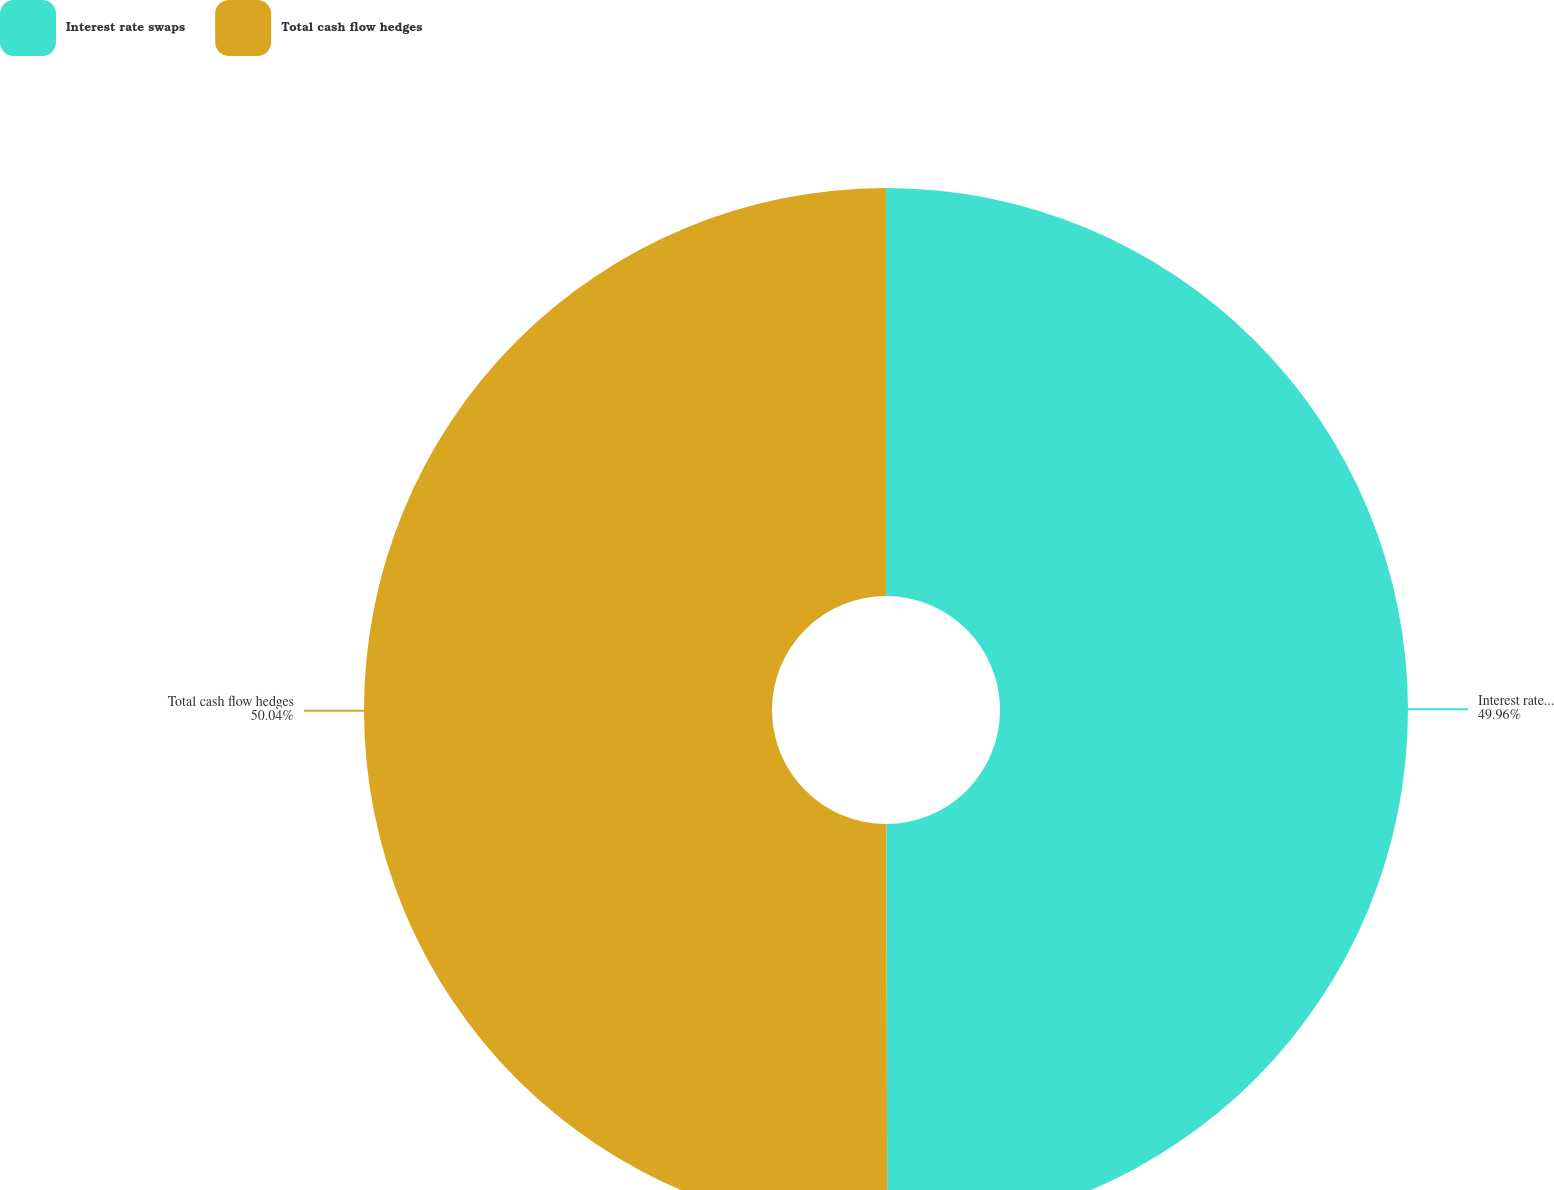Convert chart. <chart><loc_0><loc_0><loc_500><loc_500><pie_chart><fcel>Interest rate swaps<fcel>Total cash flow hedges<nl><fcel>49.96%<fcel>50.04%<nl></chart> 